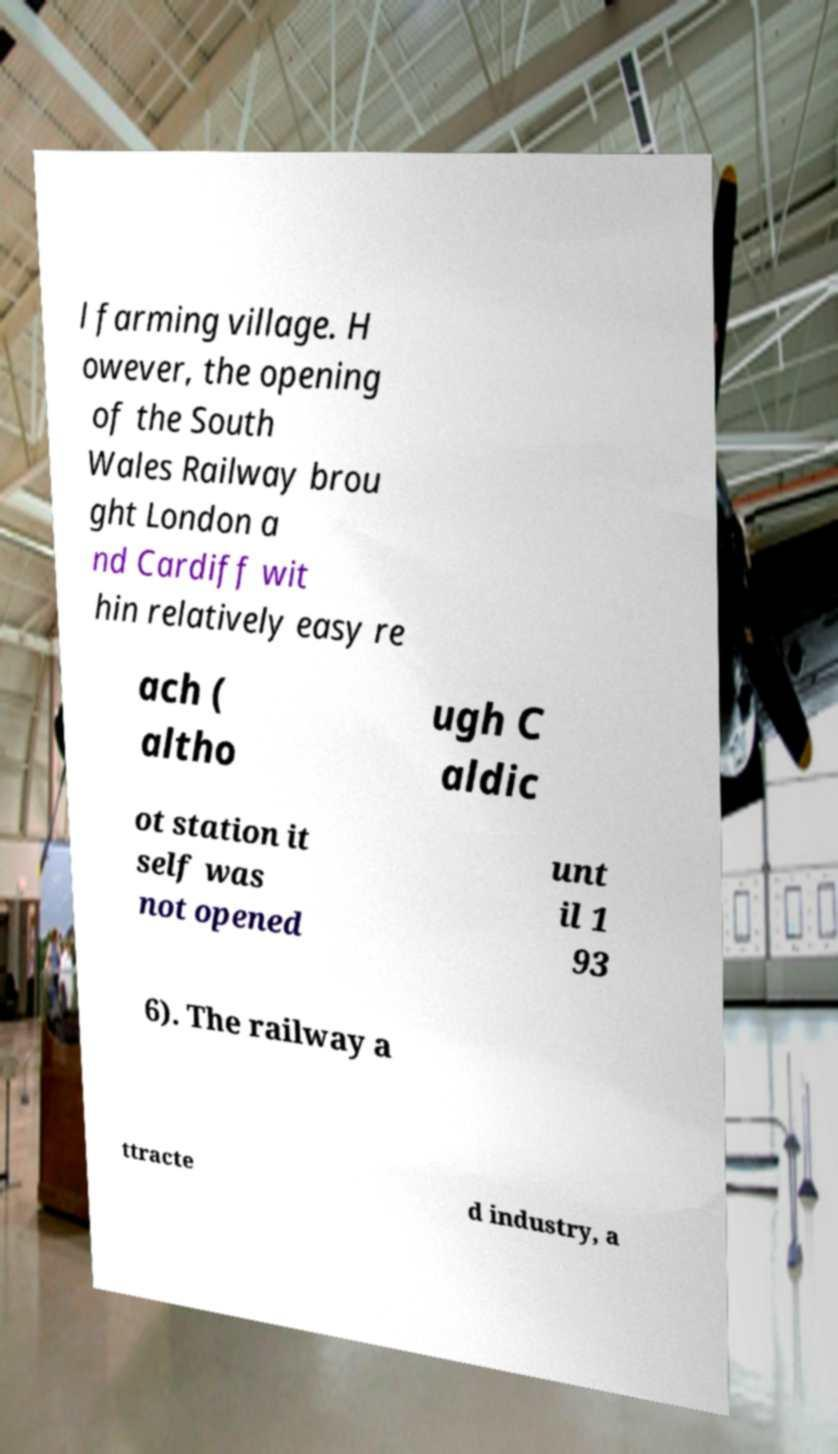There's text embedded in this image that I need extracted. Can you transcribe it verbatim? l farming village. H owever, the opening of the South Wales Railway brou ght London a nd Cardiff wit hin relatively easy re ach ( altho ugh C aldic ot station it self was not opened unt il 1 93 6). The railway a ttracte d industry, a 